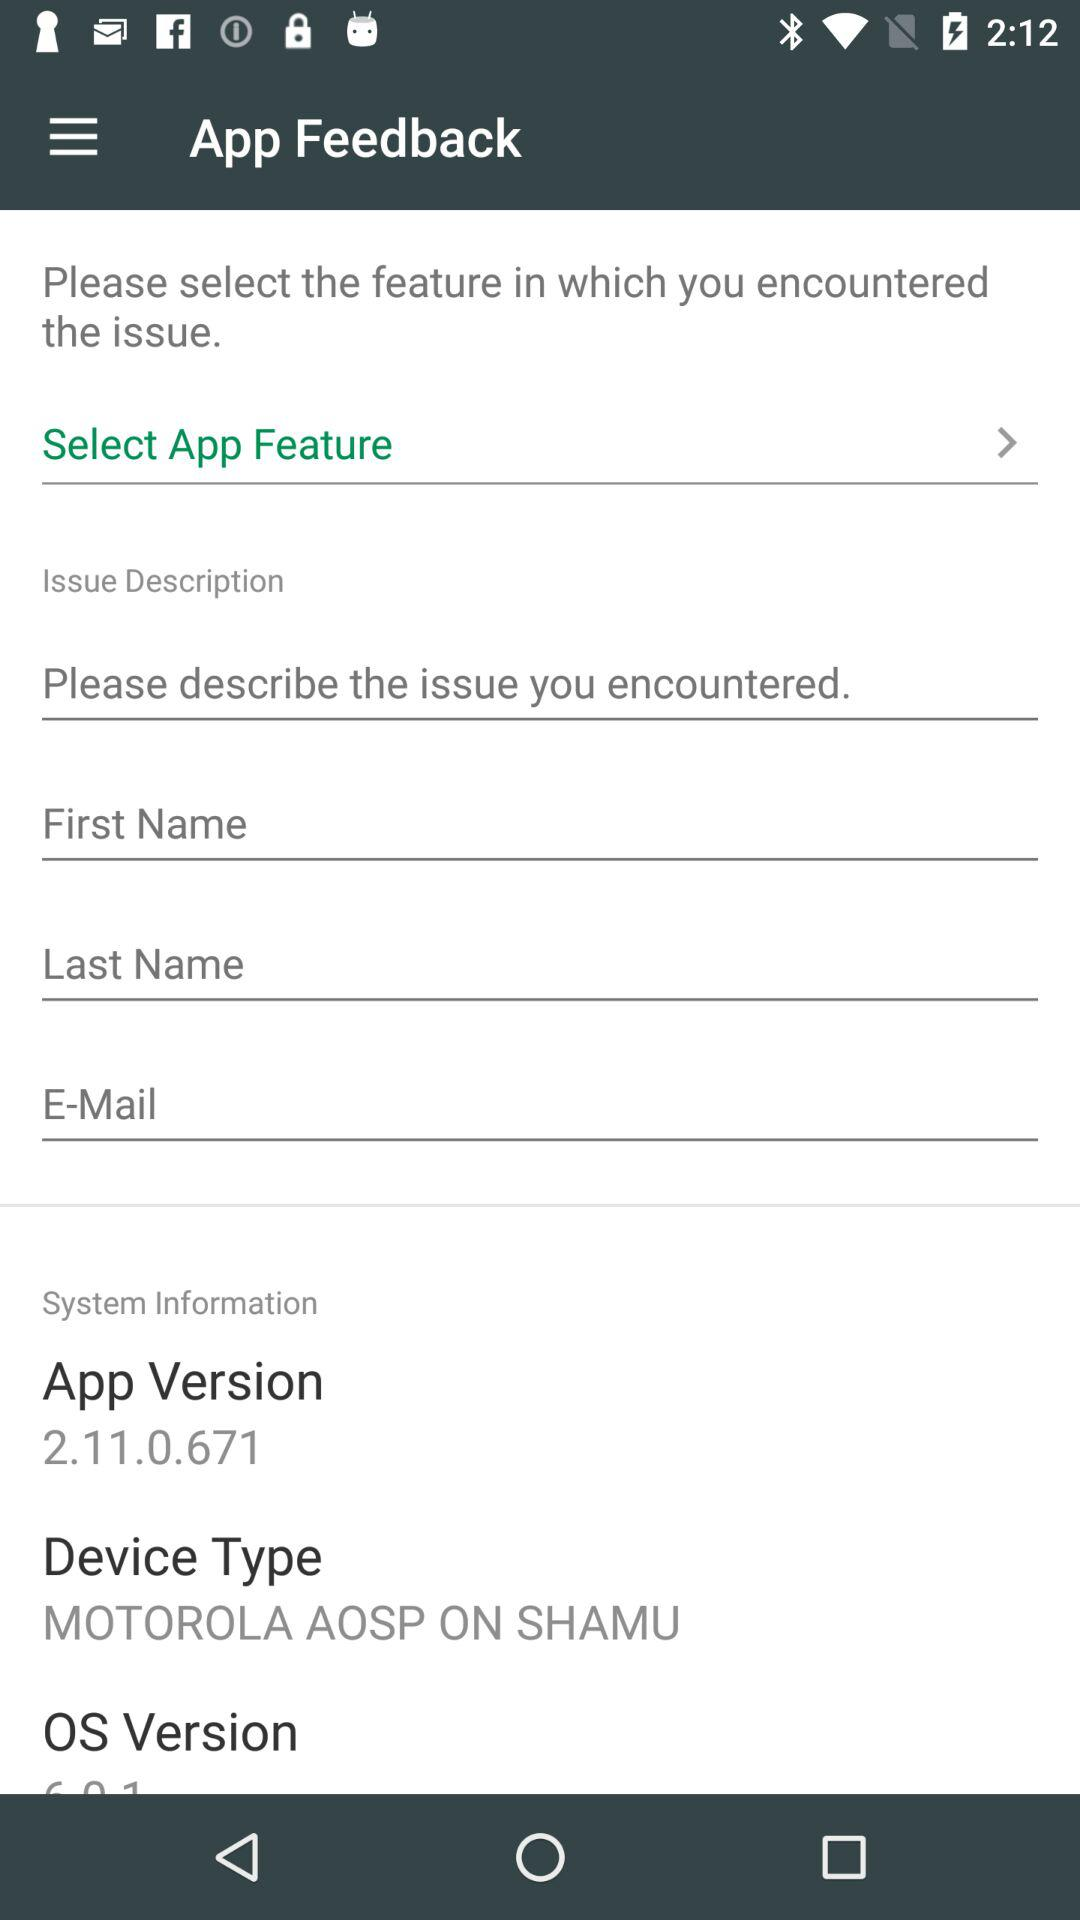Which version of the application is this? The version is 2.11.0.671. 